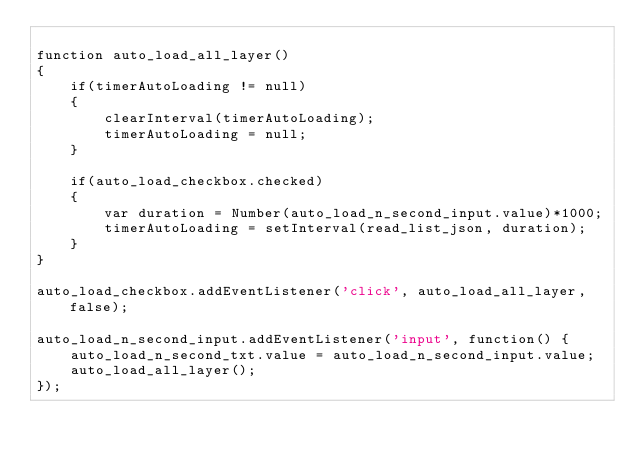Convert code to text. <code><loc_0><loc_0><loc_500><loc_500><_JavaScript_>
function auto_load_all_layer()
{
    if(timerAutoLoading != null)
    {
        clearInterval(timerAutoLoading);
        timerAutoLoading = null;
    }

    if(auto_load_checkbox.checked)
    {
        var duration = Number(auto_load_n_second_input.value)*1000;
        timerAutoLoading = setInterval(read_list_json, duration);
    }
}

auto_load_checkbox.addEventListener('click', auto_load_all_layer, false);

auto_load_n_second_input.addEventListener('input', function() {
    auto_load_n_second_txt.value = auto_load_n_second_input.value;
    auto_load_all_layer();
});</code> 